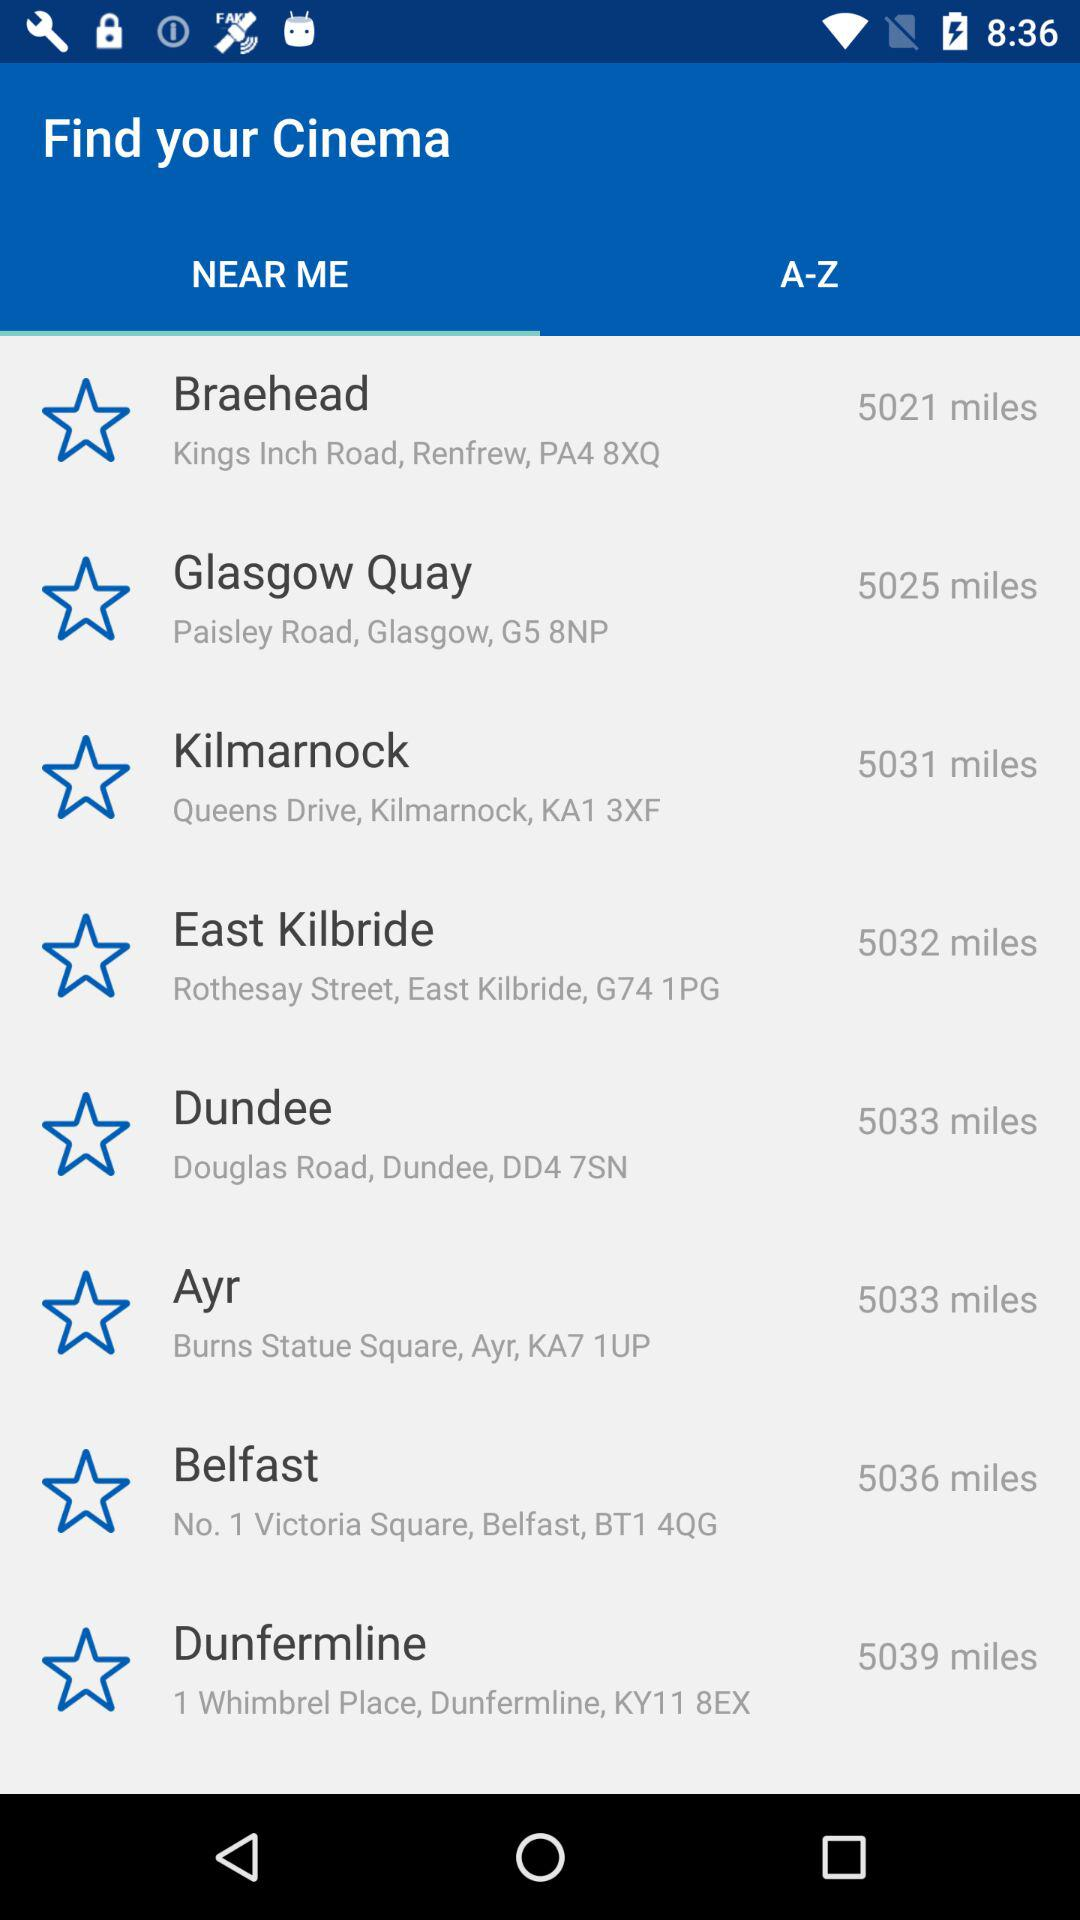What is the address of the Braehead? The address of the Braehead is Kings Inch Road, Renfrew, PA4 8XQ. 